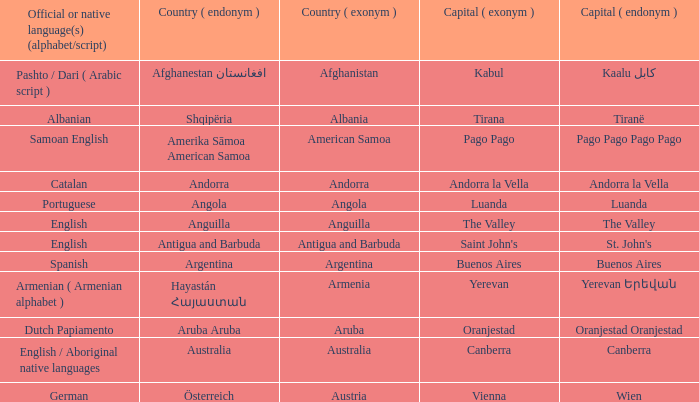What official or native languages are spoken in the country whose capital city is Canberra? English / Aboriginal native languages. Parse the full table. {'header': ['Official or native language(s) (alphabet/script)', 'Country ( endonym )', 'Country ( exonym )', 'Capital ( exonym )', 'Capital ( endonym )'], 'rows': [['Pashto / Dari ( Arabic script )', 'Afghanestan افغانستان', 'Afghanistan', 'Kabul', 'Kaalu كابل'], ['Albanian', 'Shqipëria', 'Albania', 'Tirana', 'Tiranë'], ['Samoan English', 'Amerika Sāmoa American Samoa', 'American Samoa', 'Pago Pago', 'Pago Pago Pago Pago'], ['Catalan', 'Andorra', 'Andorra', 'Andorra la Vella', 'Andorra la Vella'], ['Portuguese', 'Angola', 'Angola', 'Luanda', 'Luanda'], ['English', 'Anguilla', 'Anguilla', 'The Valley', 'The Valley'], ['English', 'Antigua and Barbuda', 'Antigua and Barbuda', "Saint John's", "St. John's"], ['Spanish', 'Argentina', 'Argentina', 'Buenos Aires', 'Buenos Aires'], ['Armenian ( Armenian alphabet )', 'Hayastán Հայաստան', 'Armenia', 'Yerevan', 'Yerevan Երեվան'], ['Dutch Papiamento', 'Aruba Aruba', 'Aruba', 'Oranjestad', 'Oranjestad Oranjestad'], ['English / Aboriginal native languages', 'Australia', 'Australia', 'Canberra', 'Canberra'], ['German', 'Österreich', 'Austria', 'Vienna', 'Wien']]} 